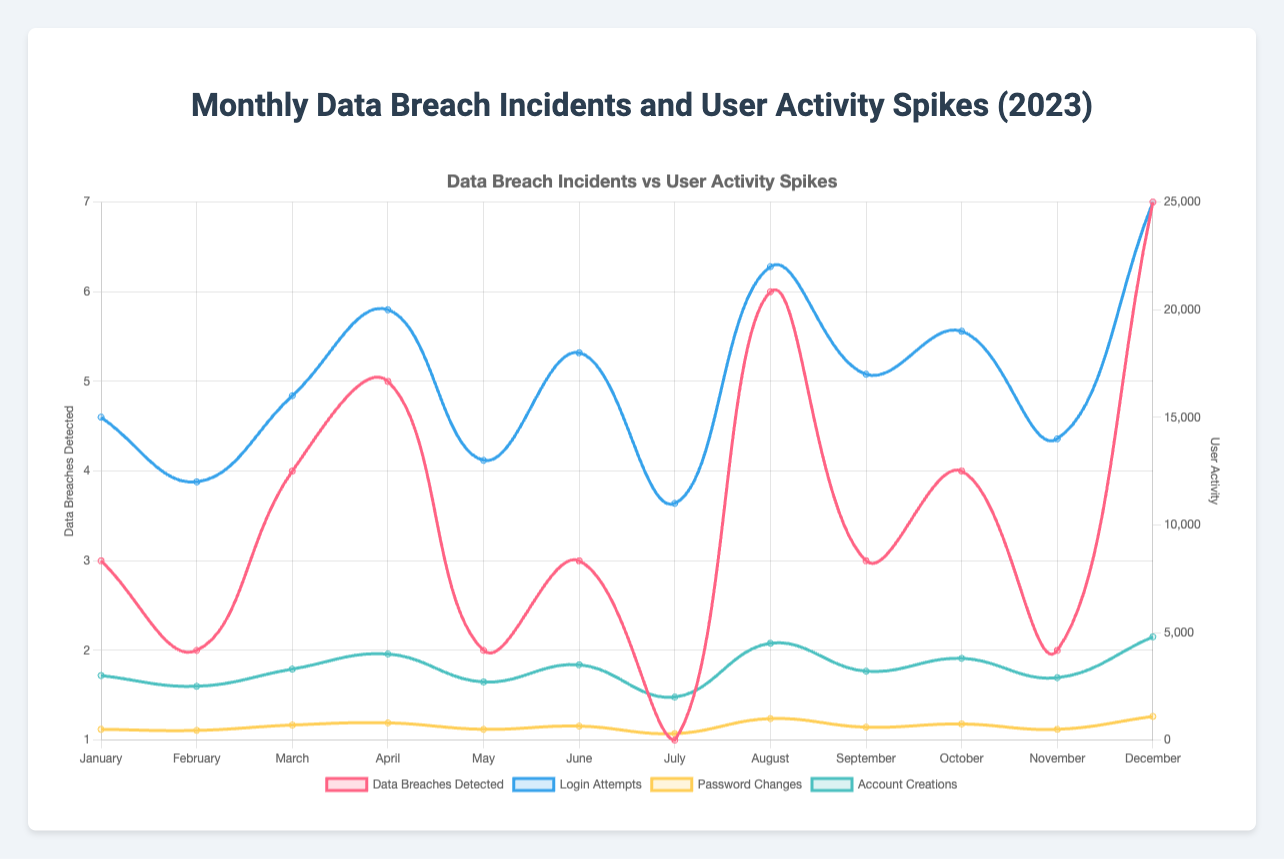Which month had the highest number of data breaches detected? By observing the red line representing the number of data breaches detected, it peaks in December with the highest value.
Answer: December How many login attempts were there in March compared to April? In March, there were 16,000 login attempts, whereas in April, there were 20,000. Comparing these, April had more login attempts than March by 4,000.
Answer: April had 4,000 more Which month had more password changes: February or August? Observing the yellow line for password changes, February had 450, while August had 1,000. This indicates that August had more password changes.
Answer: August What is the total number of account creations in January, February, and March? Summing the account creations for these months: January (3,000), February (2,500), and March (3,300). So, 3,000 + 2,500 + 3,300 = 8,800 account creations.
Answer: 8,800 In which month did the number of data breaches detected increase the most compared to the previous month? From the red line, observe the changes month over month. From July (1) to August (6), the number of breaches increased by the most, which is 5.
Answer: August What is the average number of login attempts from January to June? Sum the login attempts for each month from January to June and divide by 6. (15,000 + 12,000 + 16,000 + 20,000 + 13,000 + 18,000) / 6 = 94,000 / 6 = 15,667.
Answer: 15,667 Which month had fewer password changes: July or November? Observing the yellow line, July had 300 password changes, and November had 500. Thus, July had fewer password changes.
Answer: July How does the number of account creations in September compare to December? In September, there were 3,200 account creations, and in December, there were 4,800. Comparing these, December had 1,600 more account creations than September.
Answer: December had 1,600 more What is the total number of data breaches detected in the first half of the year (January to June)? Sum the number of breaches from January to June: 3 + 2 + 4 + 5 + 2 + 3 = 19.
Answer: 19 Which month had the highest user activity spike for login attempts? Observing the blue line for login attempts, the highest spike is in December with 25,000 login attempts.
Answer: December 